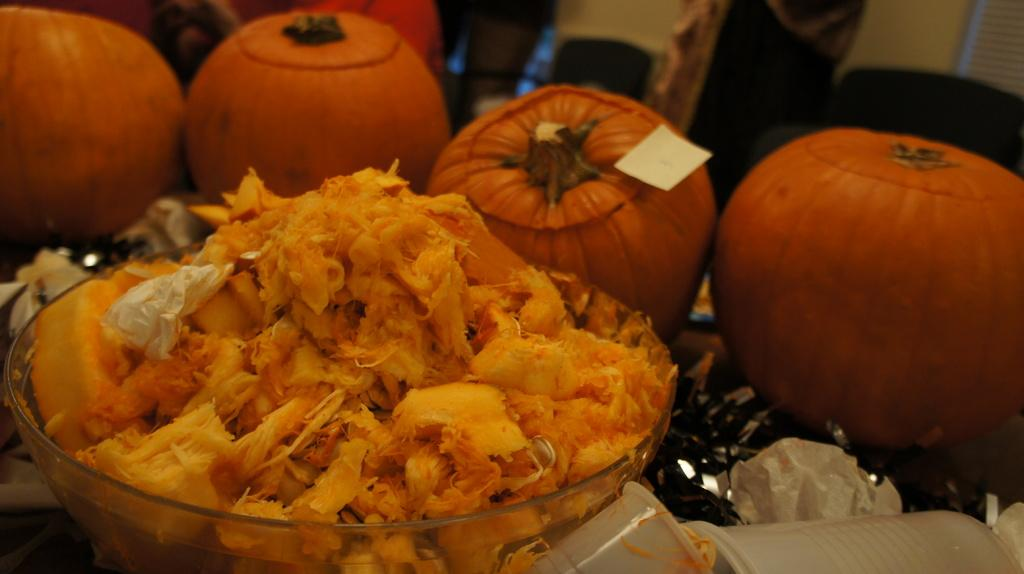What is in the bowl that is visible in the image? There is food in a bowl in the image. What other objects can be seen in the image? There are orange color pumpkins visible in the image. What type of dog is playing with the band in the image? There is no dog or band present in the image; it only features food in a bowl and orange pumpkins. 